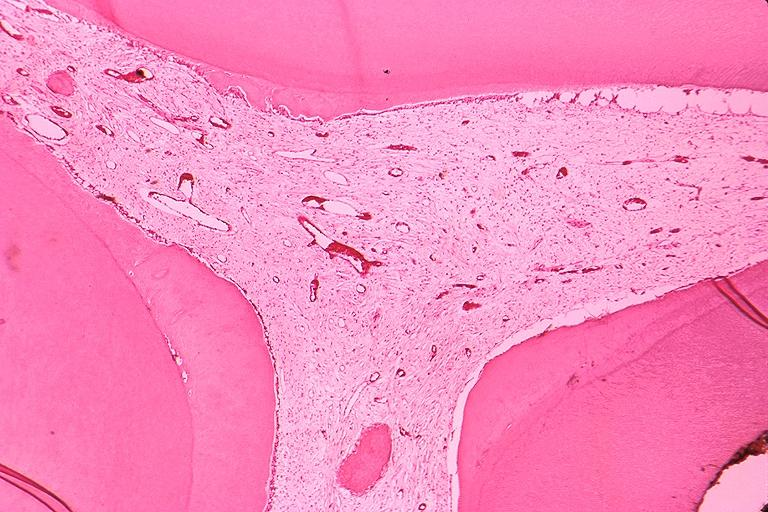s leukoplakia vocal cord present?
Answer the question using a single word or phrase. No 